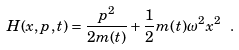Convert formula to latex. <formula><loc_0><loc_0><loc_500><loc_500>H ( x , p , t ) = \frac { p ^ { 2 } } { 2 m ( t ) } + \frac { 1 } { 2 } m ( t ) \omega ^ { 2 } x ^ { 2 } \ .</formula> 